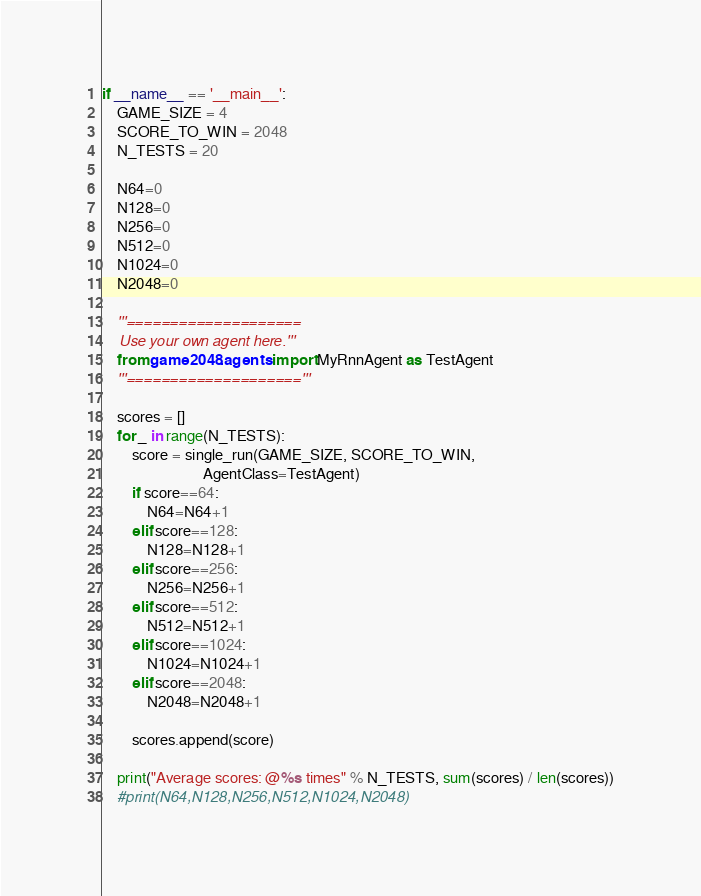Convert code to text. <code><loc_0><loc_0><loc_500><loc_500><_Python_>

if __name__ == '__main__':
    GAME_SIZE = 4
    SCORE_TO_WIN = 2048
    N_TESTS = 20

    N64=0
    N128=0
    N256=0
    N512=0
    N1024=0
    N2048=0

    '''====================
    Use your own agent here.'''
    from game2048.agents import MyRnnAgent as TestAgent
    '''===================='''

    scores = []
    for _ in range(N_TESTS):
        score = single_run(GAME_SIZE, SCORE_TO_WIN,
                           AgentClass=TestAgent)
        if score==64:
            N64=N64+1
        elif score==128:
            N128=N128+1
        elif score==256:
            N256=N256+1
        elif score==512:
            N512=N512+1
        elif score==1024:
            N1024=N1024+1
        elif score==2048:
            N2048=N2048+1

        scores.append(score)

    print("Average scores: @%s times" % N_TESTS, sum(scores) / len(scores))
    #print(N64,N128,N256,N512,N1024,N2048)
</code> 